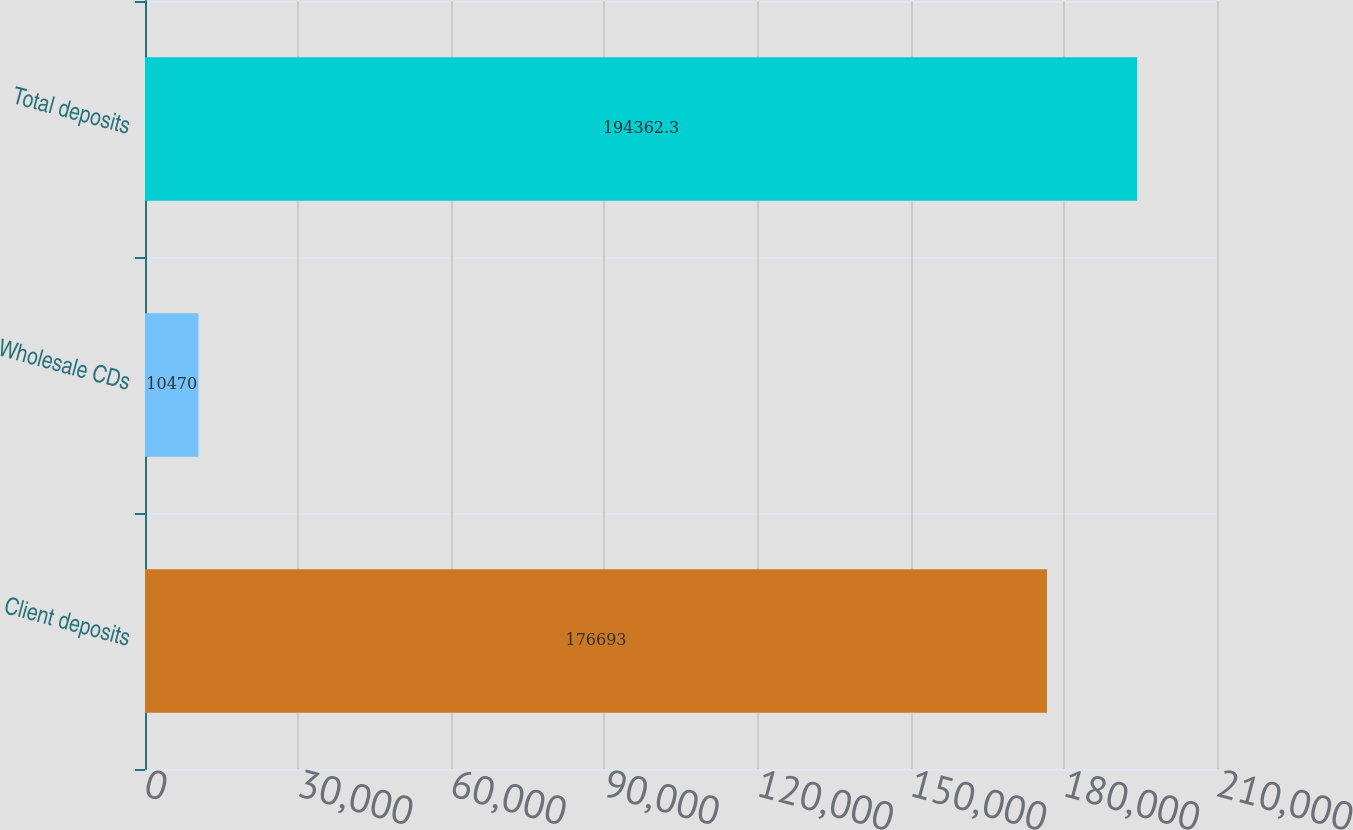<chart> <loc_0><loc_0><loc_500><loc_500><bar_chart><fcel>Client deposits<fcel>Wholesale CDs<fcel>Total deposits<nl><fcel>176693<fcel>10470<fcel>194362<nl></chart> 